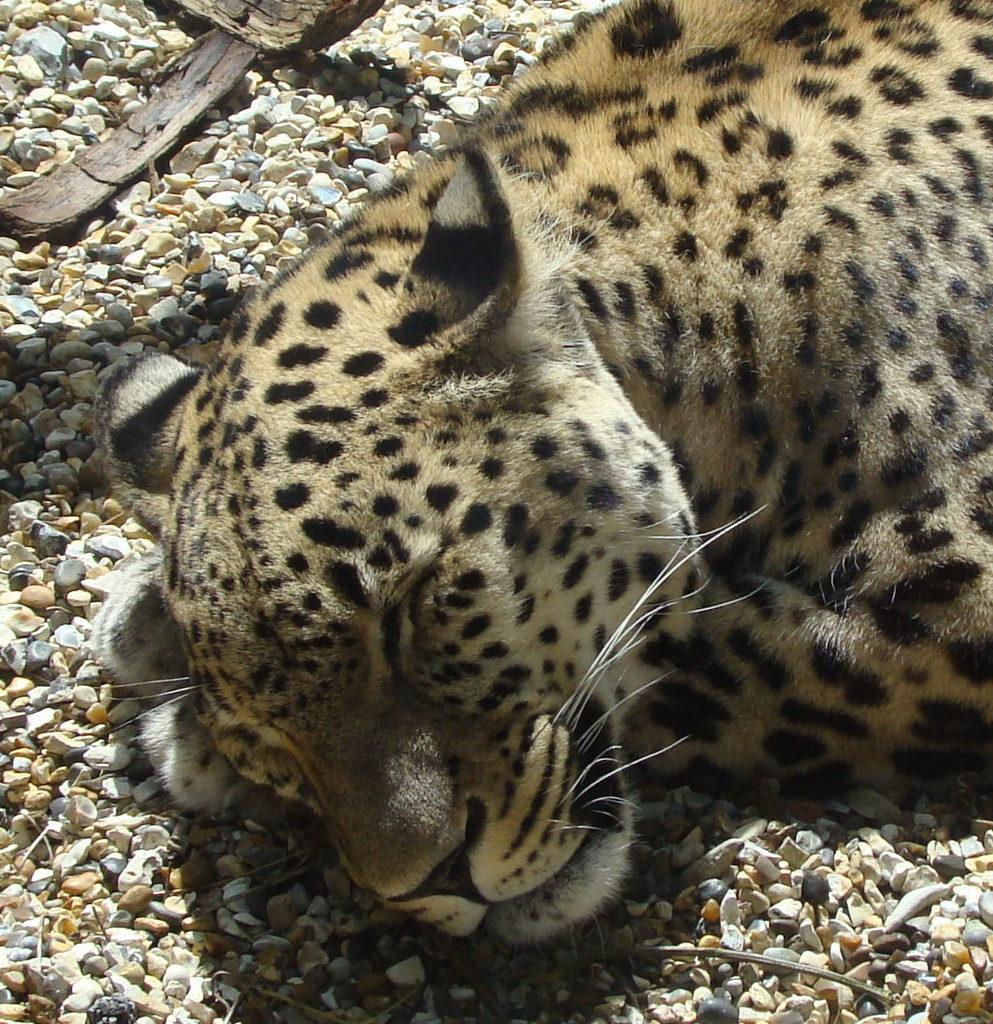What animal can be seen in the picture? There is a leopard in the picture. What is the leopard doing in the picture? The leopard is sleeping. What can be found at the bottom of the picture? There are stones at the bottom of the picture. What type of pizzas can be seen in the image? There are no pizzas present in the image. What is your opinion on the leopard's sleeping position in the image? The conversation does not include any opinions, as we are only discussing the facts present in the image. 